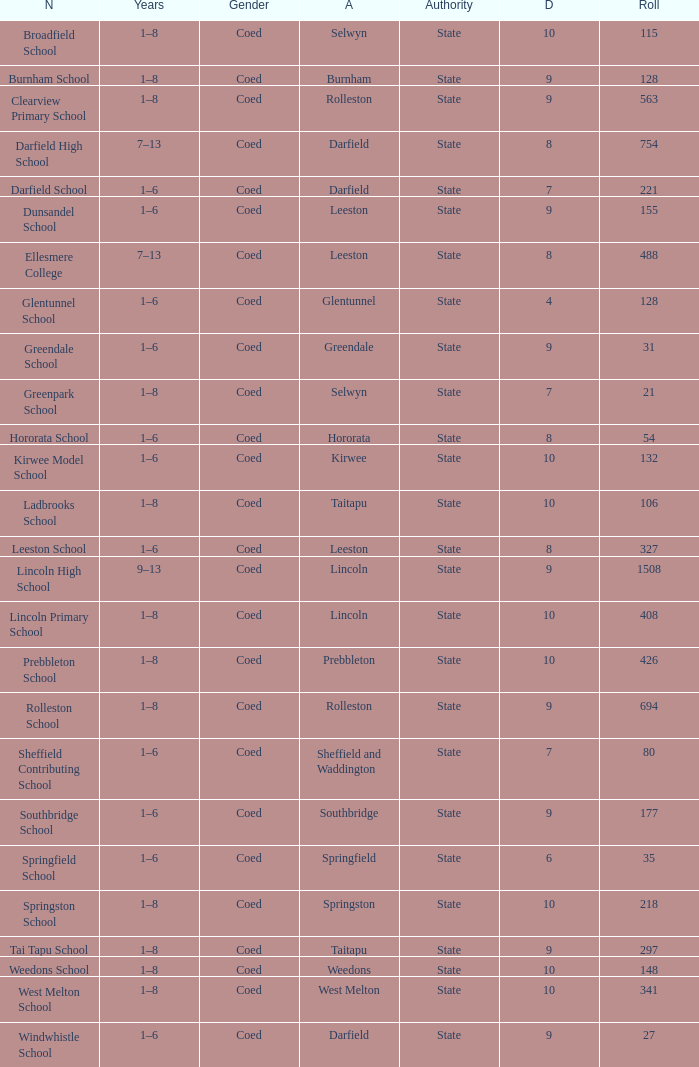Which area has a Decile of 9, and a Roll of 31? Greendale. 